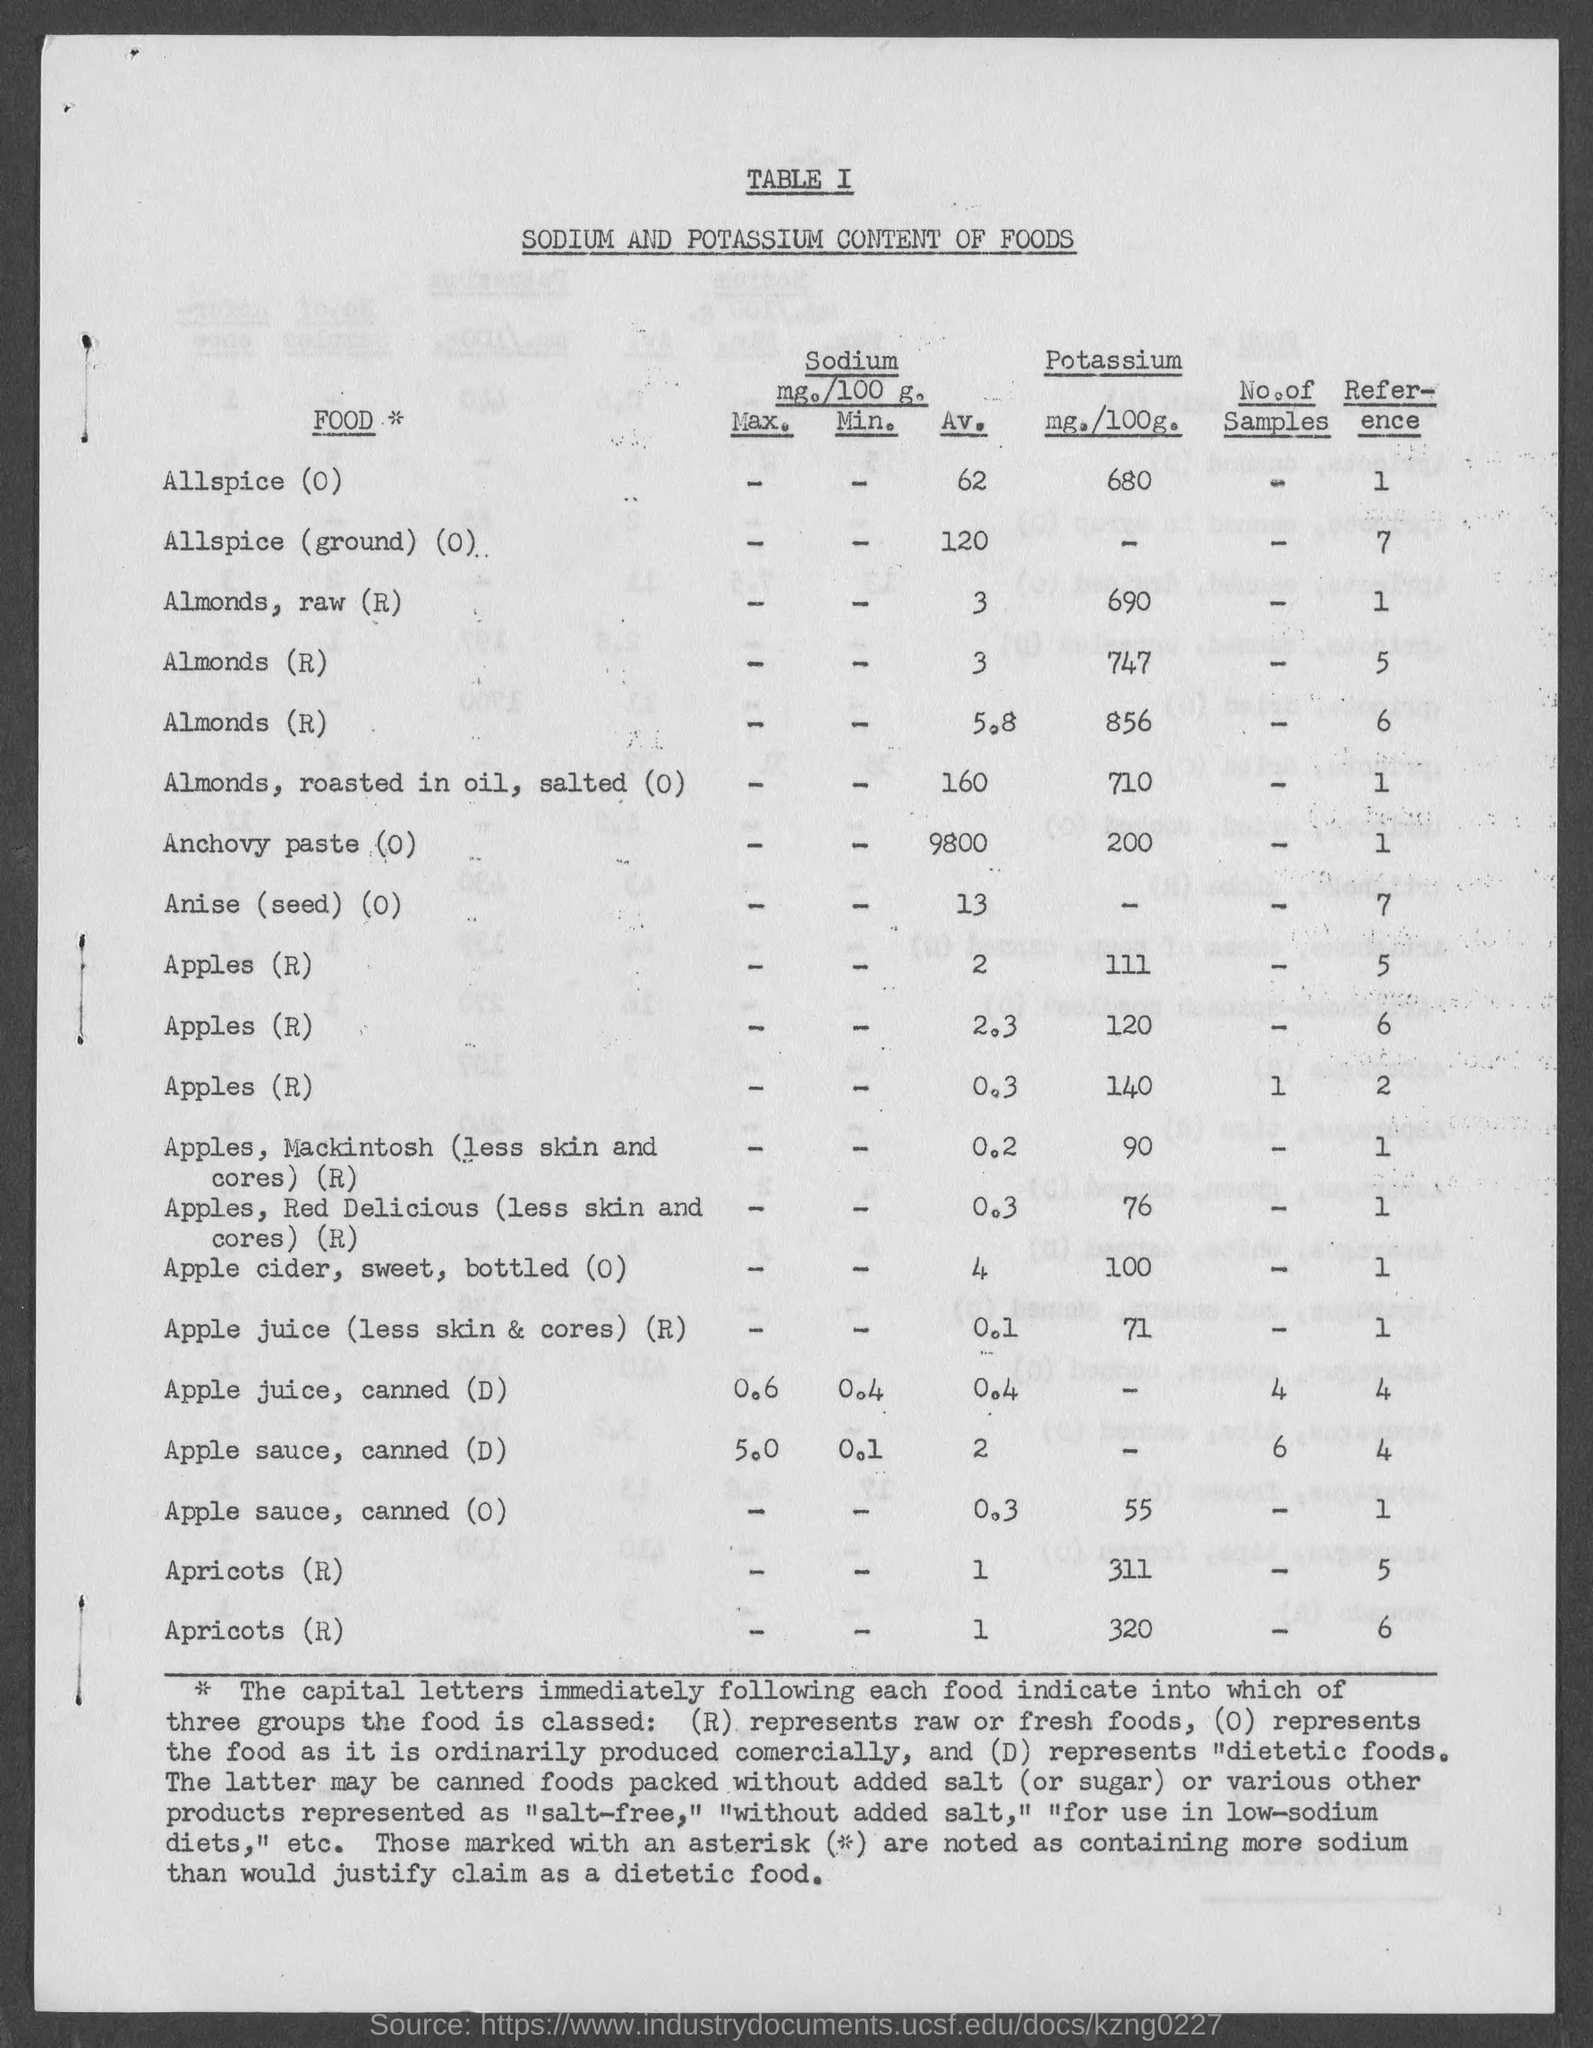What is the Av. Sodium in Allspice(0)?
Keep it short and to the point. 62. What is the Av. Sodium in Allspice(ground) (0)?
Your answer should be very brief. 120. What is the Av. Sodium in Almonds, raw (R)?
Your response must be concise. 3. What is the Av. Sodium in Almonds, roasted in oil, salted (0)?
Provide a short and direct response. 160. What is the Av. Sodium in Anchovy Paste (0)?
Your response must be concise. 9800. What is the Av. Sodium in Anise (seed) (0)?
Provide a short and direct response. 13. What is the Av. Sodium in Apple cider, sweet, bottled(0)?
Offer a very short reply. 4. What is the Potassium in Allspice (0)?
Offer a terse response. 680. What is the Potassium in Almonds, roasted in oil, salted (0)?
Provide a short and direct response. 710. What is the Potassium in Anchovy Paste (0)?
Offer a terse response. 200. 